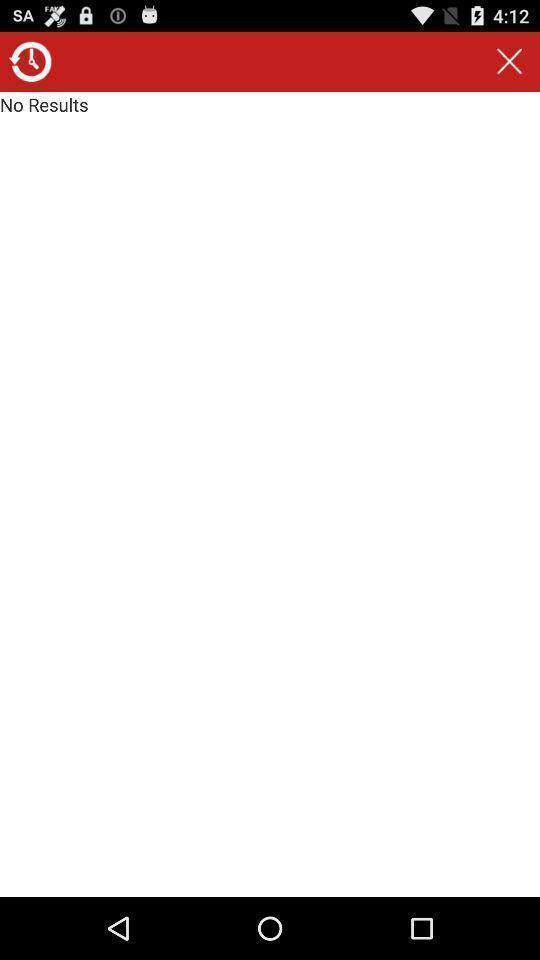Tell me what you see in this picture. Page displaying no results for a search. 